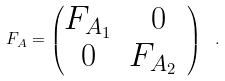Convert formula to latex. <formula><loc_0><loc_0><loc_500><loc_500>F _ { A } = \begin{pmatrix} F _ { A _ { 1 } } & 0 \\ 0 & F _ { A _ { 2 } } \ \end{pmatrix} \ .</formula> 